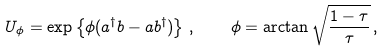<formula> <loc_0><loc_0><loc_500><loc_500>U _ { \phi } = \exp \left \{ \phi ( a ^ { \dag } b - a b ^ { \dag } ) \right \} \, , \quad \phi = \arctan \sqrt { \frac { 1 - \tau } { \tau } } \, ,</formula> 